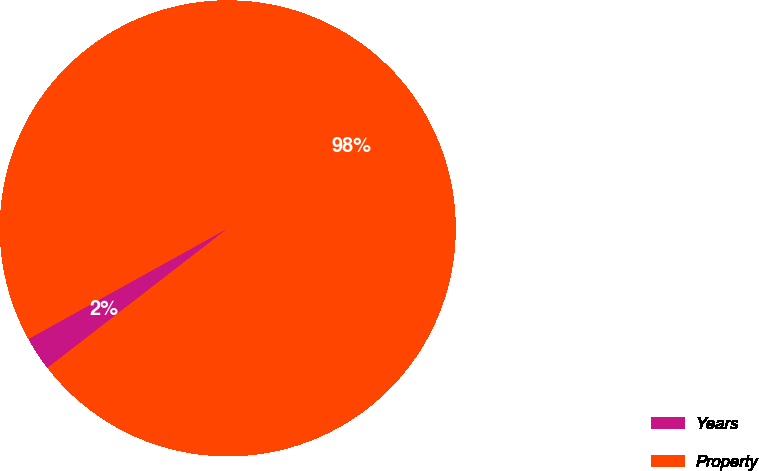Convert chart. <chart><loc_0><loc_0><loc_500><loc_500><pie_chart><fcel>Years<fcel>Property<nl><fcel>2.42%<fcel>97.58%<nl></chart> 